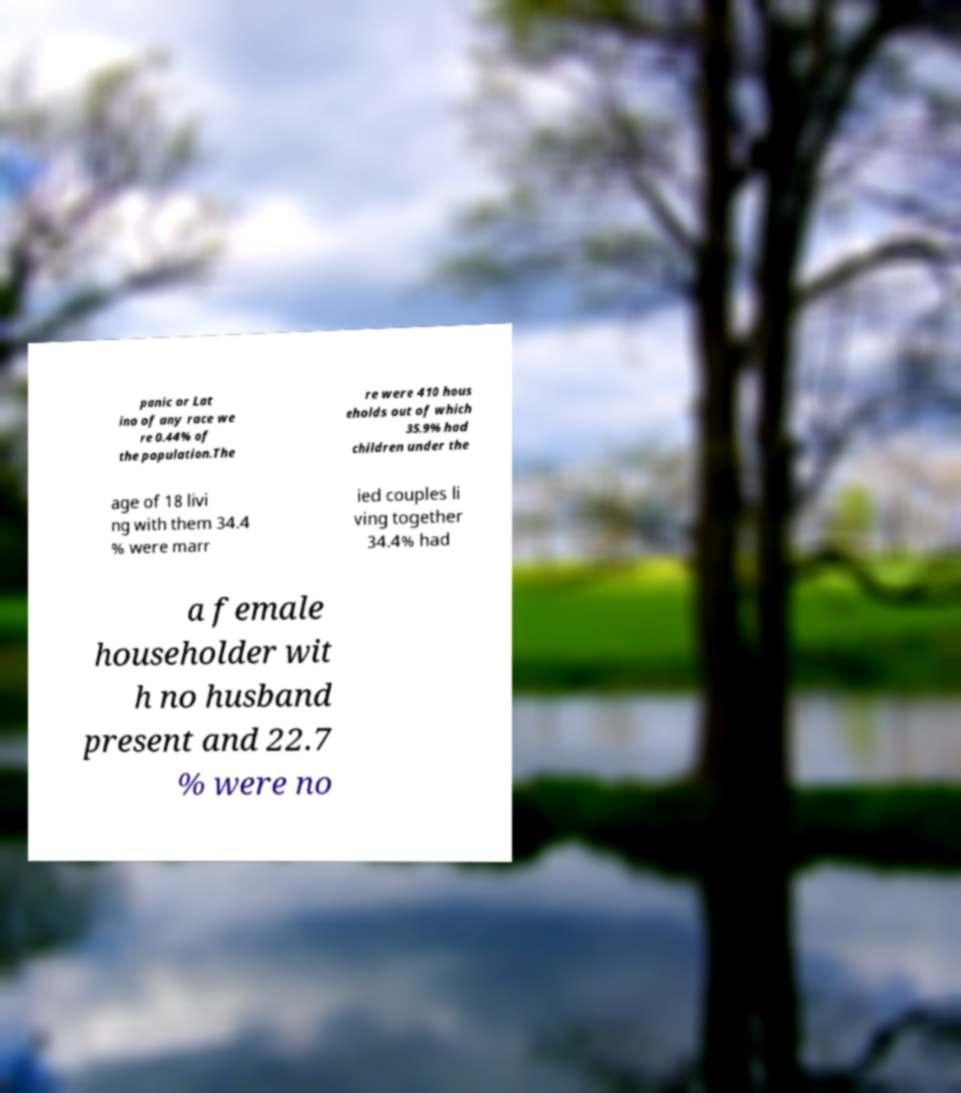For documentation purposes, I need the text within this image transcribed. Could you provide that? panic or Lat ino of any race we re 0.44% of the population.The re were 410 hous eholds out of which 35.9% had children under the age of 18 livi ng with them 34.4 % were marr ied couples li ving together 34.4% had a female householder wit h no husband present and 22.7 % were no 